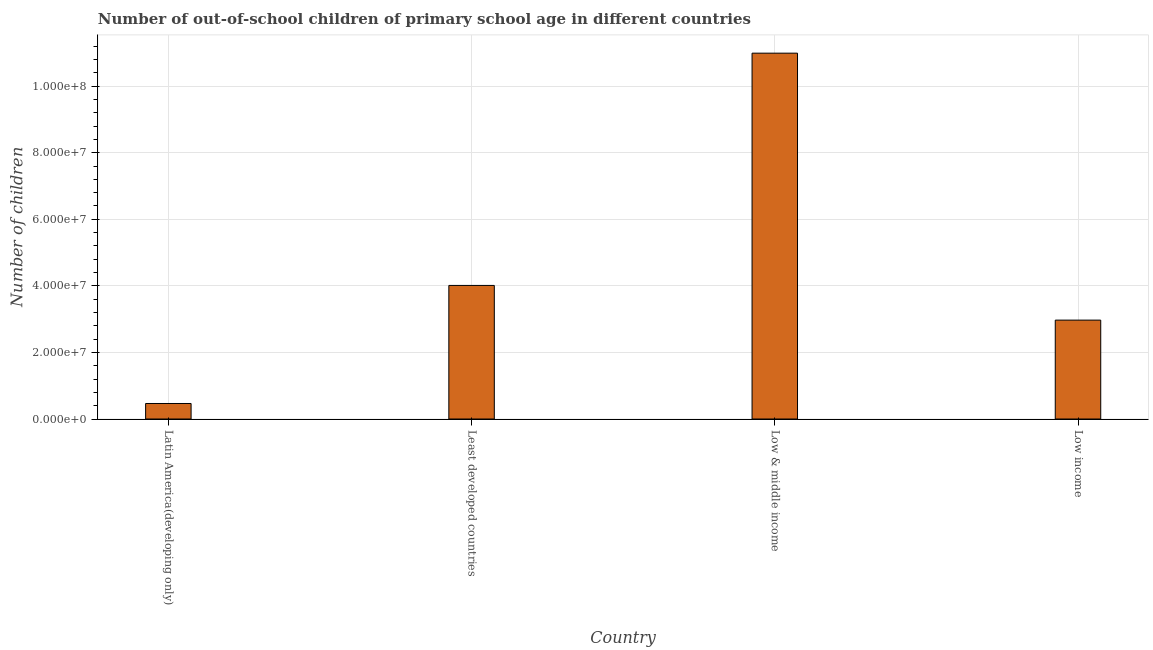What is the title of the graph?
Your response must be concise. Number of out-of-school children of primary school age in different countries. What is the label or title of the X-axis?
Provide a succinct answer. Country. What is the label or title of the Y-axis?
Make the answer very short. Number of children. What is the number of out-of-school children in Least developed countries?
Provide a succinct answer. 4.01e+07. Across all countries, what is the maximum number of out-of-school children?
Your answer should be compact. 1.10e+08. Across all countries, what is the minimum number of out-of-school children?
Offer a terse response. 4.66e+06. In which country was the number of out-of-school children minimum?
Ensure brevity in your answer.  Latin America(developing only). What is the sum of the number of out-of-school children?
Offer a terse response. 1.84e+08. What is the difference between the number of out-of-school children in Latin America(developing only) and Least developed countries?
Your answer should be compact. -3.55e+07. What is the average number of out-of-school children per country?
Your answer should be compact. 4.61e+07. What is the median number of out-of-school children?
Offer a very short reply. 3.49e+07. In how many countries, is the number of out-of-school children greater than 28000000 ?
Give a very brief answer. 3. What is the ratio of the number of out-of-school children in Latin America(developing only) to that in Least developed countries?
Give a very brief answer. 0.12. Is the number of out-of-school children in Least developed countries less than that in Low & middle income?
Ensure brevity in your answer.  Yes. What is the difference between the highest and the second highest number of out-of-school children?
Your response must be concise. 6.98e+07. What is the difference between the highest and the lowest number of out-of-school children?
Provide a succinct answer. 1.05e+08. How many bars are there?
Provide a succinct answer. 4. How many countries are there in the graph?
Offer a terse response. 4. What is the difference between two consecutive major ticks on the Y-axis?
Offer a very short reply. 2.00e+07. Are the values on the major ticks of Y-axis written in scientific E-notation?
Make the answer very short. Yes. What is the Number of children of Latin America(developing only)?
Your response must be concise. 4.66e+06. What is the Number of children in Least developed countries?
Offer a terse response. 4.01e+07. What is the Number of children in Low & middle income?
Make the answer very short. 1.10e+08. What is the Number of children of Low income?
Ensure brevity in your answer.  2.97e+07. What is the difference between the Number of children in Latin America(developing only) and Least developed countries?
Your response must be concise. -3.55e+07. What is the difference between the Number of children in Latin America(developing only) and Low & middle income?
Provide a short and direct response. -1.05e+08. What is the difference between the Number of children in Latin America(developing only) and Low income?
Give a very brief answer. -2.50e+07. What is the difference between the Number of children in Least developed countries and Low & middle income?
Your response must be concise. -6.98e+07. What is the difference between the Number of children in Least developed countries and Low income?
Your answer should be very brief. 1.04e+07. What is the difference between the Number of children in Low & middle income and Low income?
Ensure brevity in your answer.  8.02e+07. What is the ratio of the Number of children in Latin America(developing only) to that in Least developed countries?
Your answer should be very brief. 0.12. What is the ratio of the Number of children in Latin America(developing only) to that in Low & middle income?
Give a very brief answer. 0.04. What is the ratio of the Number of children in Latin America(developing only) to that in Low income?
Your answer should be compact. 0.16. What is the ratio of the Number of children in Least developed countries to that in Low & middle income?
Your answer should be very brief. 0.36. What is the ratio of the Number of children in Least developed countries to that in Low income?
Your answer should be very brief. 1.35. What is the ratio of the Number of children in Low & middle income to that in Low income?
Keep it short and to the point. 3.7. 